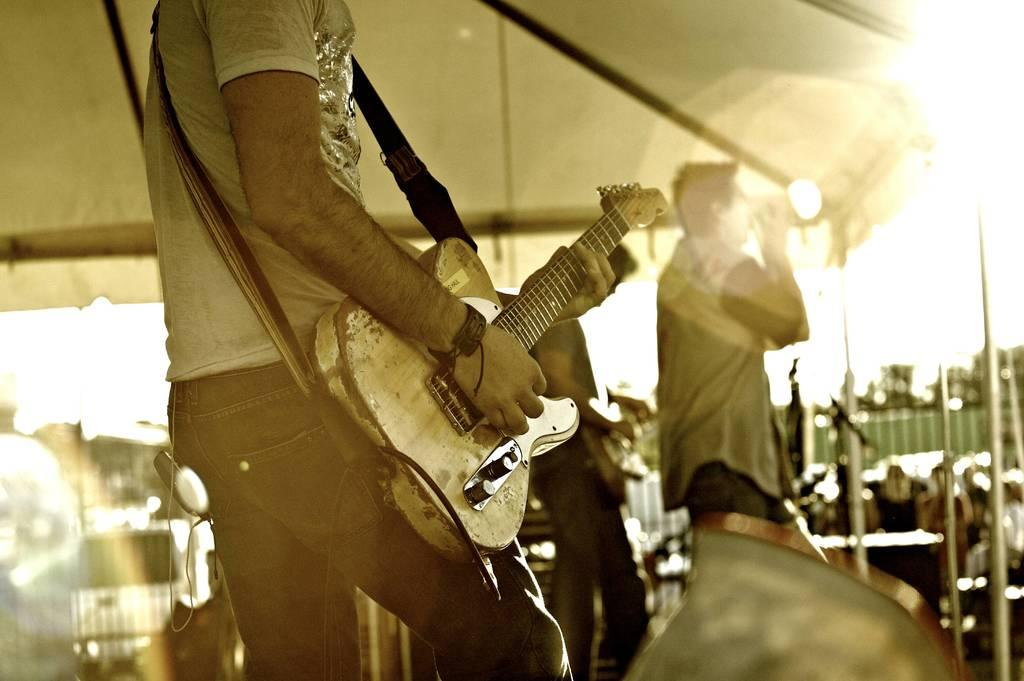What is the person in the image doing? There is a person playing a guitar in the image. What is the other person doing in the image? The other person is singing in the image. How is the singer holding the microphone? The singer is holding a microphone. What structure can be seen in the background of the image? There is a tent visible in the image. Can you see any skateboarders performing tricks near the tent in the image? There is no mention of skateboarders or any tricks being performed in the image. 